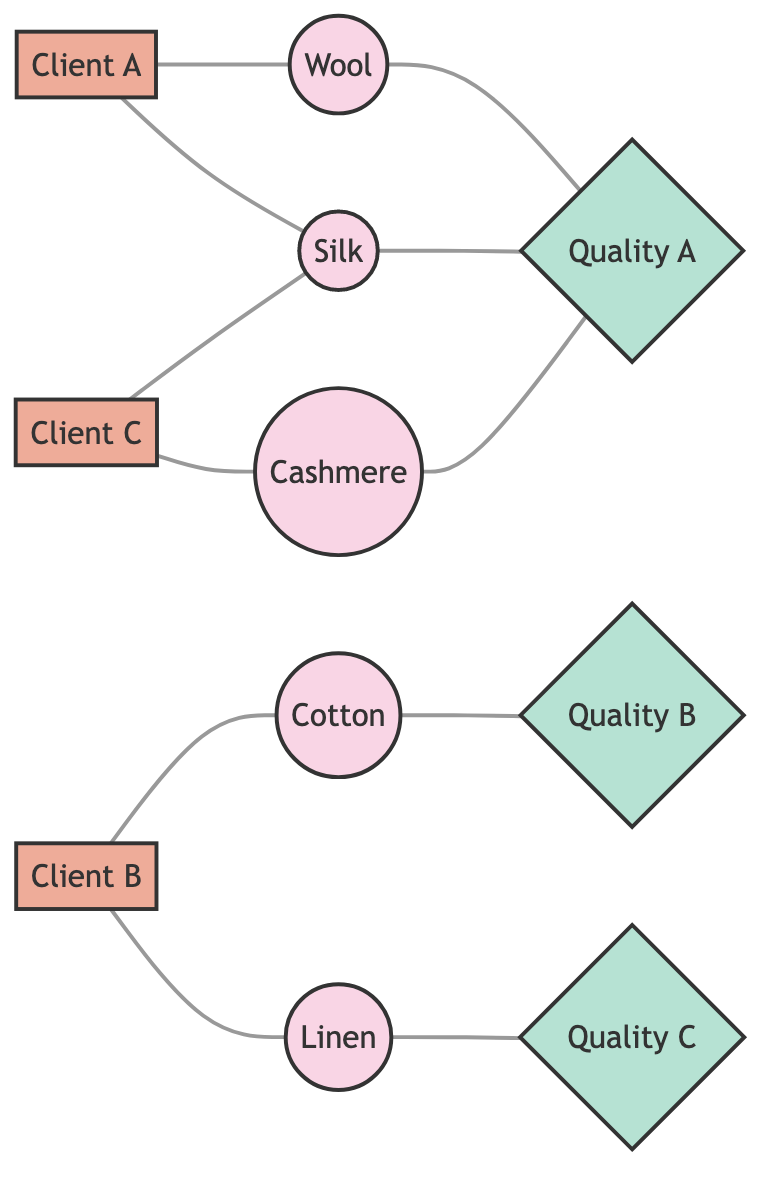What clients prefer Silk? By observing the edges connected to the Silk node, we can see that Client_A and Client_C both have connections to Silk, indicating that they prefer this material.
Answer: Client_A, Client_C How many quality ratings are represented in the diagram? There are three distinct nodes labeled as Quality: Quality_A, Quality_B, and Quality_C. This can be confirmed by counting the quality nodes in the diagram.
Answer: 3 Which material is connected to Quality_A? By reviewing the edges connected to the Quality_A node, we find that Wool, Silk, and Cashmere are all linked to Quality_A, indicating they have this quality rating.
Answer: Wool, Silk, Cashmere Which client prefers Cotton? There is a direct connection from Client_B to the Cotton node in the diagram, showing that Client_B prefers this specific material.
Answer: Client_B How many clients are connected to Cashmere? Examining the connections, Cashmere only has one edge leading from Client_C, indicating that only one client is connected to the Cashmere node in the graph.
Answer: 1 Which materials are preferred by Client_A? Client_A has two connections, one leading to Wool and another to Silk; thus, these two materials are indicated as preferred by Client_A.
Answer: Wool, Silk What is the relationship between Cashmere and Quality_A? There is an edge directly linking Cashmere to Quality_A, indicating that Cashmere is associated with this particular quality rating.
Answer: Cashmere is associated with Quality_A How many unique materials are shown in the graph? There are five distinct material nodes (Wool, Cotton, Silk, Linen, Cashmere), as can be seen from the material nodes listed in the diagram.
Answer: 5 Which material is connected to Quality_C? Through examining the connections of the Quality_C node, we can see that it is connected only to Linen, indicating that Linen has this quality rating.
Answer: Linen 